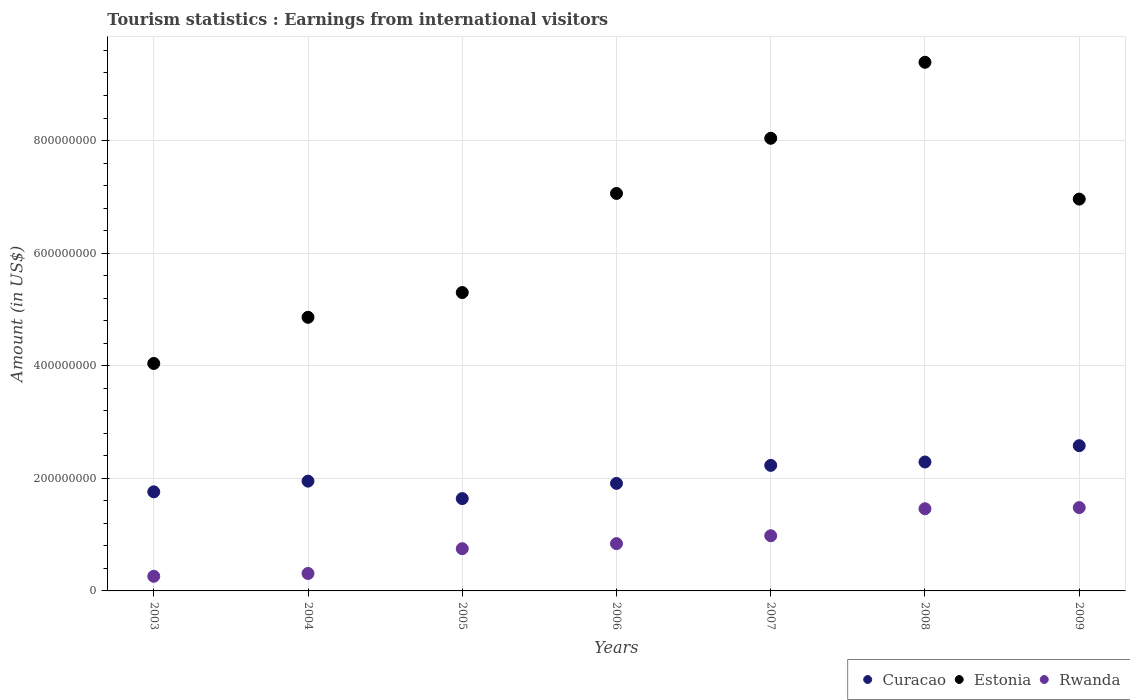What is the earnings from international visitors in Estonia in 2004?
Give a very brief answer. 4.86e+08. Across all years, what is the maximum earnings from international visitors in Rwanda?
Ensure brevity in your answer.  1.48e+08. Across all years, what is the minimum earnings from international visitors in Estonia?
Your response must be concise. 4.04e+08. What is the total earnings from international visitors in Rwanda in the graph?
Provide a short and direct response. 6.08e+08. What is the difference between the earnings from international visitors in Estonia in 2008 and that in 2009?
Give a very brief answer. 2.43e+08. What is the difference between the earnings from international visitors in Rwanda in 2005 and the earnings from international visitors in Estonia in 2008?
Provide a short and direct response. -8.64e+08. What is the average earnings from international visitors in Estonia per year?
Give a very brief answer. 6.52e+08. In the year 2005, what is the difference between the earnings from international visitors in Curacao and earnings from international visitors in Estonia?
Offer a very short reply. -3.66e+08. What is the ratio of the earnings from international visitors in Curacao in 2005 to that in 2009?
Your answer should be very brief. 0.64. Is the earnings from international visitors in Estonia in 2007 less than that in 2008?
Your response must be concise. Yes. Is the difference between the earnings from international visitors in Curacao in 2003 and 2005 greater than the difference between the earnings from international visitors in Estonia in 2003 and 2005?
Offer a terse response. Yes. What is the difference between the highest and the second highest earnings from international visitors in Rwanda?
Your answer should be very brief. 2.00e+06. What is the difference between the highest and the lowest earnings from international visitors in Rwanda?
Ensure brevity in your answer.  1.22e+08. In how many years, is the earnings from international visitors in Rwanda greater than the average earnings from international visitors in Rwanda taken over all years?
Keep it short and to the point. 3. What is the difference between two consecutive major ticks on the Y-axis?
Your response must be concise. 2.00e+08. Where does the legend appear in the graph?
Your answer should be very brief. Bottom right. What is the title of the graph?
Offer a terse response. Tourism statistics : Earnings from international visitors. Does "Guinea" appear as one of the legend labels in the graph?
Offer a terse response. No. What is the Amount (in US$) of Curacao in 2003?
Ensure brevity in your answer.  1.76e+08. What is the Amount (in US$) of Estonia in 2003?
Provide a succinct answer. 4.04e+08. What is the Amount (in US$) in Rwanda in 2003?
Provide a short and direct response. 2.60e+07. What is the Amount (in US$) in Curacao in 2004?
Provide a short and direct response. 1.95e+08. What is the Amount (in US$) in Estonia in 2004?
Make the answer very short. 4.86e+08. What is the Amount (in US$) of Rwanda in 2004?
Your answer should be compact. 3.10e+07. What is the Amount (in US$) of Curacao in 2005?
Provide a short and direct response. 1.64e+08. What is the Amount (in US$) in Estonia in 2005?
Keep it short and to the point. 5.30e+08. What is the Amount (in US$) in Rwanda in 2005?
Keep it short and to the point. 7.50e+07. What is the Amount (in US$) in Curacao in 2006?
Ensure brevity in your answer.  1.91e+08. What is the Amount (in US$) of Estonia in 2006?
Your answer should be very brief. 7.06e+08. What is the Amount (in US$) of Rwanda in 2006?
Provide a succinct answer. 8.40e+07. What is the Amount (in US$) of Curacao in 2007?
Your answer should be very brief. 2.23e+08. What is the Amount (in US$) of Estonia in 2007?
Your answer should be compact. 8.04e+08. What is the Amount (in US$) in Rwanda in 2007?
Your answer should be compact. 9.80e+07. What is the Amount (in US$) in Curacao in 2008?
Offer a very short reply. 2.29e+08. What is the Amount (in US$) of Estonia in 2008?
Keep it short and to the point. 9.39e+08. What is the Amount (in US$) of Rwanda in 2008?
Keep it short and to the point. 1.46e+08. What is the Amount (in US$) in Curacao in 2009?
Your answer should be very brief. 2.58e+08. What is the Amount (in US$) of Estonia in 2009?
Offer a terse response. 6.96e+08. What is the Amount (in US$) of Rwanda in 2009?
Make the answer very short. 1.48e+08. Across all years, what is the maximum Amount (in US$) in Curacao?
Provide a short and direct response. 2.58e+08. Across all years, what is the maximum Amount (in US$) in Estonia?
Offer a terse response. 9.39e+08. Across all years, what is the maximum Amount (in US$) of Rwanda?
Provide a short and direct response. 1.48e+08. Across all years, what is the minimum Amount (in US$) of Curacao?
Provide a succinct answer. 1.64e+08. Across all years, what is the minimum Amount (in US$) in Estonia?
Keep it short and to the point. 4.04e+08. Across all years, what is the minimum Amount (in US$) in Rwanda?
Make the answer very short. 2.60e+07. What is the total Amount (in US$) of Curacao in the graph?
Offer a very short reply. 1.44e+09. What is the total Amount (in US$) in Estonia in the graph?
Provide a short and direct response. 4.56e+09. What is the total Amount (in US$) in Rwanda in the graph?
Keep it short and to the point. 6.08e+08. What is the difference between the Amount (in US$) in Curacao in 2003 and that in 2004?
Offer a terse response. -1.90e+07. What is the difference between the Amount (in US$) in Estonia in 2003 and that in 2004?
Provide a succinct answer. -8.20e+07. What is the difference between the Amount (in US$) in Rwanda in 2003 and that in 2004?
Provide a succinct answer. -5.00e+06. What is the difference between the Amount (in US$) in Curacao in 2003 and that in 2005?
Ensure brevity in your answer.  1.20e+07. What is the difference between the Amount (in US$) of Estonia in 2003 and that in 2005?
Provide a succinct answer. -1.26e+08. What is the difference between the Amount (in US$) in Rwanda in 2003 and that in 2005?
Provide a short and direct response. -4.90e+07. What is the difference between the Amount (in US$) in Curacao in 2003 and that in 2006?
Keep it short and to the point. -1.50e+07. What is the difference between the Amount (in US$) in Estonia in 2003 and that in 2006?
Offer a terse response. -3.02e+08. What is the difference between the Amount (in US$) of Rwanda in 2003 and that in 2006?
Make the answer very short. -5.80e+07. What is the difference between the Amount (in US$) of Curacao in 2003 and that in 2007?
Make the answer very short. -4.70e+07. What is the difference between the Amount (in US$) in Estonia in 2003 and that in 2007?
Provide a succinct answer. -4.00e+08. What is the difference between the Amount (in US$) in Rwanda in 2003 and that in 2007?
Your answer should be compact. -7.20e+07. What is the difference between the Amount (in US$) in Curacao in 2003 and that in 2008?
Your response must be concise. -5.30e+07. What is the difference between the Amount (in US$) in Estonia in 2003 and that in 2008?
Your answer should be compact. -5.35e+08. What is the difference between the Amount (in US$) in Rwanda in 2003 and that in 2008?
Offer a terse response. -1.20e+08. What is the difference between the Amount (in US$) in Curacao in 2003 and that in 2009?
Keep it short and to the point. -8.20e+07. What is the difference between the Amount (in US$) in Estonia in 2003 and that in 2009?
Make the answer very short. -2.92e+08. What is the difference between the Amount (in US$) of Rwanda in 2003 and that in 2009?
Provide a short and direct response. -1.22e+08. What is the difference between the Amount (in US$) of Curacao in 2004 and that in 2005?
Offer a terse response. 3.10e+07. What is the difference between the Amount (in US$) of Estonia in 2004 and that in 2005?
Provide a short and direct response. -4.40e+07. What is the difference between the Amount (in US$) of Rwanda in 2004 and that in 2005?
Give a very brief answer. -4.40e+07. What is the difference between the Amount (in US$) in Estonia in 2004 and that in 2006?
Offer a terse response. -2.20e+08. What is the difference between the Amount (in US$) in Rwanda in 2004 and that in 2006?
Provide a succinct answer. -5.30e+07. What is the difference between the Amount (in US$) in Curacao in 2004 and that in 2007?
Offer a very short reply. -2.80e+07. What is the difference between the Amount (in US$) in Estonia in 2004 and that in 2007?
Provide a short and direct response. -3.18e+08. What is the difference between the Amount (in US$) of Rwanda in 2004 and that in 2007?
Provide a succinct answer. -6.70e+07. What is the difference between the Amount (in US$) of Curacao in 2004 and that in 2008?
Your answer should be compact. -3.40e+07. What is the difference between the Amount (in US$) of Estonia in 2004 and that in 2008?
Offer a terse response. -4.53e+08. What is the difference between the Amount (in US$) in Rwanda in 2004 and that in 2008?
Keep it short and to the point. -1.15e+08. What is the difference between the Amount (in US$) of Curacao in 2004 and that in 2009?
Your answer should be compact. -6.30e+07. What is the difference between the Amount (in US$) in Estonia in 2004 and that in 2009?
Offer a terse response. -2.10e+08. What is the difference between the Amount (in US$) in Rwanda in 2004 and that in 2009?
Offer a very short reply. -1.17e+08. What is the difference between the Amount (in US$) in Curacao in 2005 and that in 2006?
Your answer should be compact. -2.70e+07. What is the difference between the Amount (in US$) in Estonia in 2005 and that in 2006?
Your response must be concise. -1.76e+08. What is the difference between the Amount (in US$) of Rwanda in 2005 and that in 2006?
Your answer should be very brief. -9.00e+06. What is the difference between the Amount (in US$) of Curacao in 2005 and that in 2007?
Offer a terse response. -5.90e+07. What is the difference between the Amount (in US$) of Estonia in 2005 and that in 2007?
Provide a succinct answer. -2.74e+08. What is the difference between the Amount (in US$) of Rwanda in 2005 and that in 2007?
Your answer should be compact. -2.30e+07. What is the difference between the Amount (in US$) of Curacao in 2005 and that in 2008?
Offer a very short reply. -6.50e+07. What is the difference between the Amount (in US$) in Estonia in 2005 and that in 2008?
Your answer should be very brief. -4.09e+08. What is the difference between the Amount (in US$) of Rwanda in 2005 and that in 2008?
Your answer should be very brief. -7.10e+07. What is the difference between the Amount (in US$) in Curacao in 2005 and that in 2009?
Offer a terse response. -9.40e+07. What is the difference between the Amount (in US$) of Estonia in 2005 and that in 2009?
Your response must be concise. -1.66e+08. What is the difference between the Amount (in US$) of Rwanda in 2005 and that in 2009?
Your answer should be compact. -7.30e+07. What is the difference between the Amount (in US$) in Curacao in 2006 and that in 2007?
Provide a short and direct response. -3.20e+07. What is the difference between the Amount (in US$) in Estonia in 2006 and that in 2007?
Offer a terse response. -9.80e+07. What is the difference between the Amount (in US$) in Rwanda in 2006 and that in 2007?
Ensure brevity in your answer.  -1.40e+07. What is the difference between the Amount (in US$) in Curacao in 2006 and that in 2008?
Your response must be concise. -3.80e+07. What is the difference between the Amount (in US$) in Estonia in 2006 and that in 2008?
Offer a very short reply. -2.33e+08. What is the difference between the Amount (in US$) in Rwanda in 2006 and that in 2008?
Offer a terse response. -6.20e+07. What is the difference between the Amount (in US$) of Curacao in 2006 and that in 2009?
Provide a short and direct response. -6.70e+07. What is the difference between the Amount (in US$) in Rwanda in 2006 and that in 2009?
Give a very brief answer. -6.40e+07. What is the difference between the Amount (in US$) of Curacao in 2007 and that in 2008?
Make the answer very short. -6.00e+06. What is the difference between the Amount (in US$) in Estonia in 2007 and that in 2008?
Your answer should be compact. -1.35e+08. What is the difference between the Amount (in US$) in Rwanda in 2007 and that in 2008?
Provide a succinct answer. -4.80e+07. What is the difference between the Amount (in US$) of Curacao in 2007 and that in 2009?
Keep it short and to the point. -3.50e+07. What is the difference between the Amount (in US$) in Estonia in 2007 and that in 2009?
Your response must be concise. 1.08e+08. What is the difference between the Amount (in US$) in Rwanda in 2007 and that in 2009?
Ensure brevity in your answer.  -5.00e+07. What is the difference between the Amount (in US$) of Curacao in 2008 and that in 2009?
Ensure brevity in your answer.  -2.90e+07. What is the difference between the Amount (in US$) in Estonia in 2008 and that in 2009?
Offer a terse response. 2.43e+08. What is the difference between the Amount (in US$) in Curacao in 2003 and the Amount (in US$) in Estonia in 2004?
Your response must be concise. -3.10e+08. What is the difference between the Amount (in US$) in Curacao in 2003 and the Amount (in US$) in Rwanda in 2004?
Your answer should be compact. 1.45e+08. What is the difference between the Amount (in US$) in Estonia in 2003 and the Amount (in US$) in Rwanda in 2004?
Keep it short and to the point. 3.73e+08. What is the difference between the Amount (in US$) of Curacao in 2003 and the Amount (in US$) of Estonia in 2005?
Make the answer very short. -3.54e+08. What is the difference between the Amount (in US$) of Curacao in 2003 and the Amount (in US$) of Rwanda in 2005?
Offer a very short reply. 1.01e+08. What is the difference between the Amount (in US$) in Estonia in 2003 and the Amount (in US$) in Rwanda in 2005?
Ensure brevity in your answer.  3.29e+08. What is the difference between the Amount (in US$) of Curacao in 2003 and the Amount (in US$) of Estonia in 2006?
Offer a very short reply. -5.30e+08. What is the difference between the Amount (in US$) of Curacao in 2003 and the Amount (in US$) of Rwanda in 2006?
Your answer should be very brief. 9.20e+07. What is the difference between the Amount (in US$) in Estonia in 2003 and the Amount (in US$) in Rwanda in 2006?
Offer a very short reply. 3.20e+08. What is the difference between the Amount (in US$) of Curacao in 2003 and the Amount (in US$) of Estonia in 2007?
Keep it short and to the point. -6.28e+08. What is the difference between the Amount (in US$) in Curacao in 2003 and the Amount (in US$) in Rwanda in 2007?
Provide a succinct answer. 7.80e+07. What is the difference between the Amount (in US$) in Estonia in 2003 and the Amount (in US$) in Rwanda in 2007?
Keep it short and to the point. 3.06e+08. What is the difference between the Amount (in US$) in Curacao in 2003 and the Amount (in US$) in Estonia in 2008?
Ensure brevity in your answer.  -7.63e+08. What is the difference between the Amount (in US$) of Curacao in 2003 and the Amount (in US$) of Rwanda in 2008?
Make the answer very short. 3.00e+07. What is the difference between the Amount (in US$) of Estonia in 2003 and the Amount (in US$) of Rwanda in 2008?
Make the answer very short. 2.58e+08. What is the difference between the Amount (in US$) of Curacao in 2003 and the Amount (in US$) of Estonia in 2009?
Offer a terse response. -5.20e+08. What is the difference between the Amount (in US$) of Curacao in 2003 and the Amount (in US$) of Rwanda in 2009?
Keep it short and to the point. 2.80e+07. What is the difference between the Amount (in US$) of Estonia in 2003 and the Amount (in US$) of Rwanda in 2009?
Offer a very short reply. 2.56e+08. What is the difference between the Amount (in US$) of Curacao in 2004 and the Amount (in US$) of Estonia in 2005?
Your response must be concise. -3.35e+08. What is the difference between the Amount (in US$) of Curacao in 2004 and the Amount (in US$) of Rwanda in 2005?
Provide a short and direct response. 1.20e+08. What is the difference between the Amount (in US$) of Estonia in 2004 and the Amount (in US$) of Rwanda in 2005?
Your response must be concise. 4.11e+08. What is the difference between the Amount (in US$) of Curacao in 2004 and the Amount (in US$) of Estonia in 2006?
Give a very brief answer. -5.11e+08. What is the difference between the Amount (in US$) in Curacao in 2004 and the Amount (in US$) in Rwanda in 2006?
Give a very brief answer. 1.11e+08. What is the difference between the Amount (in US$) in Estonia in 2004 and the Amount (in US$) in Rwanda in 2006?
Provide a succinct answer. 4.02e+08. What is the difference between the Amount (in US$) in Curacao in 2004 and the Amount (in US$) in Estonia in 2007?
Your response must be concise. -6.09e+08. What is the difference between the Amount (in US$) of Curacao in 2004 and the Amount (in US$) of Rwanda in 2007?
Make the answer very short. 9.70e+07. What is the difference between the Amount (in US$) of Estonia in 2004 and the Amount (in US$) of Rwanda in 2007?
Give a very brief answer. 3.88e+08. What is the difference between the Amount (in US$) of Curacao in 2004 and the Amount (in US$) of Estonia in 2008?
Provide a short and direct response. -7.44e+08. What is the difference between the Amount (in US$) in Curacao in 2004 and the Amount (in US$) in Rwanda in 2008?
Offer a terse response. 4.90e+07. What is the difference between the Amount (in US$) in Estonia in 2004 and the Amount (in US$) in Rwanda in 2008?
Offer a very short reply. 3.40e+08. What is the difference between the Amount (in US$) in Curacao in 2004 and the Amount (in US$) in Estonia in 2009?
Keep it short and to the point. -5.01e+08. What is the difference between the Amount (in US$) in Curacao in 2004 and the Amount (in US$) in Rwanda in 2009?
Keep it short and to the point. 4.70e+07. What is the difference between the Amount (in US$) in Estonia in 2004 and the Amount (in US$) in Rwanda in 2009?
Make the answer very short. 3.38e+08. What is the difference between the Amount (in US$) of Curacao in 2005 and the Amount (in US$) of Estonia in 2006?
Offer a very short reply. -5.42e+08. What is the difference between the Amount (in US$) of Curacao in 2005 and the Amount (in US$) of Rwanda in 2006?
Your response must be concise. 8.00e+07. What is the difference between the Amount (in US$) of Estonia in 2005 and the Amount (in US$) of Rwanda in 2006?
Make the answer very short. 4.46e+08. What is the difference between the Amount (in US$) of Curacao in 2005 and the Amount (in US$) of Estonia in 2007?
Give a very brief answer. -6.40e+08. What is the difference between the Amount (in US$) of Curacao in 2005 and the Amount (in US$) of Rwanda in 2007?
Give a very brief answer. 6.60e+07. What is the difference between the Amount (in US$) in Estonia in 2005 and the Amount (in US$) in Rwanda in 2007?
Your answer should be compact. 4.32e+08. What is the difference between the Amount (in US$) in Curacao in 2005 and the Amount (in US$) in Estonia in 2008?
Ensure brevity in your answer.  -7.75e+08. What is the difference between the Amount (in US$) in Curacao in 2005 and the Amount (in US$) in Rwanda in 2008?
Keep it short and to the point. 1.80e+07. What is the difference between the Amount (in US$) in Estonia in 2005 and the Amount (in US$) in Rwanda in 2008?
Your response must be concise. 3.84e+08. What is the difference between the Amount (in US$) in Curacao in 2005 and the Amount (in US$) in Estonia in 2009?
Ensure brevity in your answer.  -5.32e+08. What is the difference between the Amount (in US$) in Curacao in 2005 and the Amount (in US$) in Rwanda in 2009?
Your response must be concise. 1.60e+07. What is the difference between the Amount (in US$) in Estonia in 2005 and the Amount (in US$) in Rwanda in 2009?
Ensure brevity in your answer.  3.82e+08. What is the difference between the Amount (in US$) in Curacao in 2006 and the Amount (in US$) in Estonia in 2007?
Ensure brevity in your answer.  -6.13e+08. What is the difference between the Amount (in US$) in Curacao in 2006 and the Amount (in US$) in Rwanda in 2007?
Your answer should be very brief. 9.30e+07. What is the difference between the Amount (in US$) in Estonia in 2006 and the Amount (in US$) in Rwanda in 2007?
Provide a succinct answer. 6.08e+08. What is the difference between the Amount (in US$) of Curacao in 2006 and the Amount (in US$) of Estonia in 2008?
Ensure brevity in your answer.  -7.48e+08. What is the difference between the Amount (in US$) in Curacao in 2006 and the Amount (in US$) in Rwanda in 2008?
Provide a short and direct response. 4.50e+07. What is the difference between the Amount (in US$) of Estonia in 2006 and the Amount (in US$) of Rwanda in 2008?
Make the answer very short. 5.60e+08. What is the difference between the Amount (in US$) of Curacao in 2006 and the Amount (in US$) of Estonia in 2009?
Offer a very short reply. -5.05e+08. What is the difference between the Amount (in US$) in Curacao in 2006 and the Amount (in US$) in Rwanda in 2009?
Make the answer very short. 4.30e+07. What is the difference between the Amount (in US$) of Estonia in 2006 and the Amount (in US$) of Rwanda in 2009?
Keep it short and to the point. 5.58e+08. What is the difference between the Amount (in US$) in Curacao in 2007 and the Amount (in US$) in Estonia in 2008?
Make the answer very short. -7.16e+08. What is the difference between the Amount (in US$) in Curacao in 2007 and the Amount (in US$) in Rwanda in 2008?
Your answer should be compact. 7.70e+07. What is the difference between the Amount (in US$) in Estonia in 2007 and the Amount (in US$) in Rwanda in 2008?
Make the answer very short. 6.58e+08. What is the difference between the Amount (in US$) in Curacao in 2007 and the Amount (in US$) in Estonia in 2009?
Offer a terse response. -4.73e+08. What is the difference between the Amount (in US$) in Curacao in 2007 and the Amount (in US$) in Rwanda in 2009?
Provide a short and direct response. 7.50e+07. What is the difference between the Amount (in US$) of Estonia in 2007 and the Amount (in US$) of Rwanda in 2009?
Keep it short and to the point. 6.56e+08. What is the difference between the Amount (in US$) of Curacao in 2008 and the Amount (in US$) of Estonia in 2009?
Your answer should be very brief. -4.67e+08. What is the difference between the Amount (in US$) in Curacao in 2008 and the Amount (in US$) in Rwanda in 2009?
Ensure brevity in your answer.  8.10e+07. What is the difference between the Amount (in US$) of Estonia in 2008 and the Amount (in US$) of Rwanda in 2009?
Make the answer very short. 7.91e+08. What is the average Amount (in US$) of Curacao per year?
Provide a short and direct response. 2.05e+08. What is the average Amount (in US$) of Estonia per year?
Ensure brevity in your answer.  6.52e+08. What is the average Amount (in US$) of Rwanda per year?
Give a very brief answer. 8.69e+07. In the year 2003, what is the difference between the Amount (in US$) in Curacao and Amount (in US$) in Estonia?
Provide a succinct answer. -2.28e+08. In the year 2003, what is the difference between the Amount (in US$) of Curacao and Amount (in US$) of Rwanda?
Provide a short and direct response. 1.50e+08. In the year 2003, what is the difference between the Amount (in US$) in Estonia and Amount (in US$) in Rwanda?
Your answer should be very brief. 3.78e+08. In the year 2004, what is the difference between the Amount (in US$) in Curacao and Amount (in US$) in Estonia?
Offer a terse response. -2.91e+08. In the year 2004, what is the difference between the Amount (in US$) of Curacao and Amount (in US$) of Rwanda?
Provide a short and direct response. 1.64e+08. In the year 2004, what is the difference between the Amount (in US$) of Estonia and Amount (in US$) of Rwanda?
Offer a very short reply. 4.55e+08. In the year 2005, what is the difference between the Amount (in US$) of Curacao and Amount (in US$) of Estonia?
Your answer should be compact. -3.66e+08. In the year 2005, what is the difference between the Amount (in US$) of Curacao and Amount (in US$) of Rwanda?
Provide a succinct answer. 8.90e+07. In the year 2005, what is the difference between the Amount (in US$) of Estonia and Amount (in US$) of Rwanda?
Ensure brevity in your answer.  4.55e+08. In the year 2006, what is the difference between the Amount (in US$) in Curacao and Amount (in US$) in Estonia?
Provide a short and direct response. -5.15e+08. In the year 2006, what is the difference between the Amount (in US$) of Curacao and Amount (in US$) of Rwanda?
Give a very brief answer. 1.07e+08. In the year 2006, what is the difference between the Amount (in US$) of Estonia and Amount (in US$) of Rwanda?
Keep it short and to the point. 6.22e+08. In the year 2007, what is the difference between the Amount (in US$) of Curacao and Amount (in US$) of Estonia?
Provide a succinct answer. -5.81e+08. In the year 2007, what is the difference between the Amount (in US$) of Curacao and Amount (in US$) of Rwanda?
Offer a terse response. 1.25e+08. In the year 2007, what is the difference between the Amount (in US$) in Estonia and Amount (in US$) in Rwanda?
Keep it short and to the point. 7.06e+08. In the year 2008, what is the difference between the Amount (in US$) in Curacao and Amount (in US$) in Estonia?
Offer a terse response. -7.10e+08. In the year 2008, what is the difference between the Amount (in US$) of Curacao and Amount (in US$) of Rwanda?
Keep it short and to the point. 8.30e+07. In the year 2008, what is the difference between the Amount (in US$) in Estonia and Amount (in US$) in Rwanda?
Offer a terse response. 7.93e+08. In the year 2009, what is the difference between the Amount (in US$) in Curacao and Amount (in US$) in Estonia?
Provide a succinct answer. -4.38e+08. In the year 2009, what is the difference between the Amount (in US$) of Curacao and Amount (in US$) of Rwanda?
Make the answer very short. 1.10e+08. In the year 2009, what is the difference between the Amount (in US$) in Estonia and Amount (in US$) in Rwanda?
Give a very brief answer. 5.48e+08. What is the ratio of the Amount (in US$) in Curacao in 2003 to that in 2004?
Provide a short and direct response. 0.9. What is the ratio of the Amount (in US$) in Estonia in 2003 to that in 2004?
Offer a terse response. 0.83. What is the ratio of the Amount (in US$) in Rwanda in 2003 to that in 2004?
Make the answer very short. 0.84. What is the ratio of the Amount (in US$) in Curacao in 2003 to that in 2005?
Your answer should be very brief. 1.07. What is the ratio of the Amount (in US$) in Estonia in 2003 to that in 2005?
Your response must be concise. 0.76. What is the ratio of the Amount (in US$) in Rwanda in 2003 to that in 2005?
Your response must be concise. 0.35. What is the ratio of the Amount (in US$) in Curacao in 2003 to that in 2006?
Provide a succinct answer. 0.92. What is the ratio of the Amount (in US$) of Estonia in 2003 to that in 2006?
Your answer should be compact. 0.57. What is the ratio of the Amount (in US$) of Rwanda in 2003 to that in 2006?
Provide a succinct answer. 0.31. What is the ratio of the Amount (in US$) of Curacao in 2003 to that in 2007?
Your answer should be compact. 0.79. What is the ratio of the Amount (in US$) of Estonia in 2003 to that in 2007?
Your response must be concise. 0.5. What is the ratio of the Amount (in US$) in Rwanda in 2003 to that in 2007?
Your response must be concise. 0.27. What is the ratio of the Amount (in US$) of Curacao in 2003 to that in 2008?
Make the answer very short. 0.77. What is the ratio of the Amount (in US$) in Estonia in 2003 to that in 2008?
Offer a very short reply. 0.43. What is the ratio of the Amount (in US$) of Rwanda in 2003 to that in 2008?
Offer a very short reply. 0.18. What is the ratio of the Amount (in US$) in Curacao in 2003 to that in 2009?
Your response must be concise. 0.68. What is the ratio of the Amount (in US$) of Estonia in 2003 to that in 2009?
Make the answer very short. 0.58. What is the ratio of the Amount (in US$) of Rwanda in 2003 to that in 2009?
Provide a short and direct response. 0.18. What is the ratio of the Amount (in US$) in Curacao in 2004 to that in 2005?
Your answer should be very brief. 1.19. What is the ratio of the Amount (in US$) in Estonia in 2004 to that in 2005?
Your answer should be compact. 0.92. What is the ratio of the Amount (in US$) of Rwanda in 2004 to that in 2005?
Your answer should be compact. 0.41. What is the ratio of the Amount (in US$) of Curacao in 2004 to that in 2006?
Provide a succinct answer. 1.02. What is the ratio of the Amount (in US$) in Estonia in 2004 to that in 2006?
Keep it short and to the point. 0.69. What is the ratio of the Amount (in US$) in Rwanda in 2004 to that in 2006?
Offer a very short reply. 0.37. What is the ratio of the Amount (in US$) of Curacao in 2004 to that in 2007?
Offer a very short reply. 0.87. What is the ratio of the Amount (in US$) in Estonia in 2004 to that in 2007?
Your answer should be very brief. 0.6. What is the ratio of the Amount (in US$) of Rwanda in 2004 to that in 2007?
Provide a succinct answer. 0.32. What is the ratio of the Amount (in US$) in Curacao in 2004 to that in 2008?
Provide a succinct answer. 0.85. What is the ratio of the Amount (in US$) of Estonia in 2004 to that in 2008?
Give a very brief answer. 0.52. What is the ratio of the Amount (in US$) of Rwanda in 2004 to that in 2008?
Your answer should be very brief. 0.21. What is the ratio of the Amount (in US$) in Curacao in 2004 to that in 2009?
Keep it short and to the point. 0.76. What is the ratio of the Amount (in US$) of Estonia in 2004 to that in 2009?
Your answer should be very brief. 0.7. What is the ratio of the Amount (in US$) of Rwanda in 2004 to that in 2009?
Your answer should be very brief. 0.21. What is the ratio of the Amount (in US$) in Curacao in 2005 to that in 2006?
Your answer should be compact. 0.86. What is the ratio of the Amount (in US$) of Estonia in 2005 to that in 2006?
Your answer should be very brief. 0.75. What is the ratio of the Amount (in US$) in Rwanda in 2005 to that in 2006?
Offer a terse response. 0.89. What is the ratio of the Amount (in US$) in Curacao in 2005 to that in 2007?
Your answer should be compact. 0.74. What is the ratio of the Amount (in US$) of Estonia in 2005 to that in 2007?
Your answer should be very brief. 0.66. What is the ratio of the Amount (in US$) of Rwanda in 2005 to that in 2007?
Make the answer very short. 0.77. What is the ratio of the Amount (in US$) in Curacao in 2005 to that in 2008?
Offer a terse response. 0.72. What is the ratio of the Amount (in US$) of Estonia in 2005 to that in 2008?
Make the answer very short. 0.56. What is the ratio of the Amount (in US$) in Rwanda in 2005 to that in 2008?
Ensure brevity in your answer.  0.51. What is the ratio of the Amount (in US$) in Curacao in 2005 to that in 2009?
Give a very brief answer. 0.64. What is the ratio of the Amount (in US$) in Estonia in 2005 to that in 2009?
Provide a succinct answer. 0.76. What is the ratio of the Amount (in US$) of Rwanda in 2005 to that in 2009?
Keep it short and to the point. 0.51. What is the ratio of the Amount (in US$) of Curacao in 2006 to that in 2007?
Make the answer very short. 0.86. What is the ratio of the Amount (in US$) in Estonia in 2006 to that in 2007?
Provide a succinct answer. 0.88. What is the ratio of the Amount (in US$) in Rwanda in 2006 to that in 2007?
Provide a short and direct response. 0.86. What is the ratio of the Amount (in US$) in Curacao in 2006 to that in 2008?
Your response must be concise. 0.83. What is the ratio of the Amount (in US$) in Estonia in 2006 to that in 2008?
Provide a short and direct response. 0.75. What is the ratio of the Amount (in US$) in Rwanda in 2006 to that in 2008?
Give a very brief answer. 0.58. What is the ratio of the Amount (in US$) in Curacao in 2006 to that in 2009?
Your answer should be compact. 0.74. What is the ratio of the Amount (in US$) of Estonia in 2006 to that in 2009?
Offer a terse response. 1.01. What is the ratio of the Amount (in US$) in Rwanda in 2006 to that in 2009?
Your answer should be very brief. 0.57. What is the ratio of the Amount (in US$) in Curacao in 2007 to that in 2008?
Your response must be concise. 0.97. What is the ratio of the Amount (in US$) of Estonia in 2007 to that in 2008?
Your answer should be very brief. 0.86. What is the ratio of the Amount (in US$) of Rwanda in 2007 to that in 2008?
Your response must be concise. 0.67. What is the ratio of the Amount (in US$) in Curacao in 2007 to that in 2009?
Your answer should be very brief. 0.86. What is the ratio of the Amount (in US$) in Estonia in 2007 to that in 2009?
Offer a very short reply. 1.16. What is the ratio of the Amount (in US$) of Rwanda in 2007 to that in 2009?
Offer a terse response. 0.66. What is the ratio of the Amount (in US$) in Curacao in 2008 to that in 2009?
Your response must be concise. 0.89. What is the ratio of the Amount (in US$) of Estonia in 2008 to that in 2009?
Your answer should be compact. 1.35. What is the ratio of the Amount (in US$) of Rwanda in 2008 to that in 2009?
Make the answer very short. 0.99. What is the difference between the highest and the second highest Amount (in US$) of Curacao?
Keep it short and to the point. 2.90e+07. What is the difference between the highest and the second highest Amount (in US$) of Estonia?
Give a very brief answer. 1.35e+08. What is the difference between the highest and the second highest Amount (in US$) of Rwanda?
Provide a succinct answer. 2.00e+06. What is the difference between the highest and the lowest Amount (in US$) in Curacao?
Offer a terse response. 9.40e+07. What is the difference between the highest and the lowest Amount (in US$) of Estonia?
Keep it short and to the point. 5.35e+08. What is the difference between the highest and the lowest Amount (in US$) of Rwanda?
Offer a very short reply. 1.22e+08. 